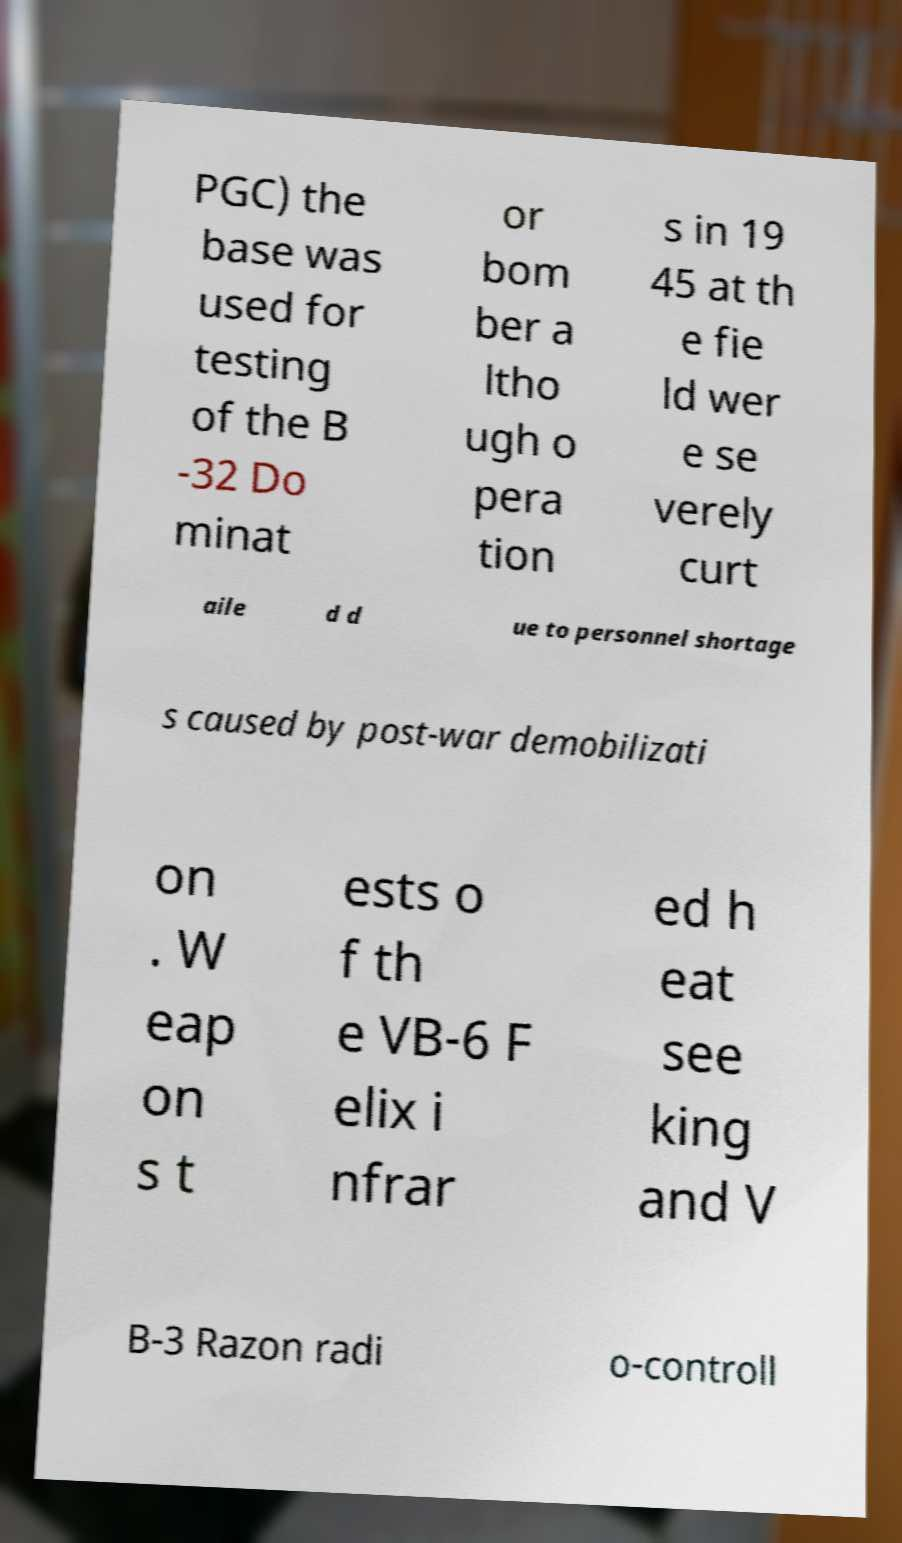Could you assist in decoding the text presented in this image and type it out clearly? PGC) the base was used for testing of the B -32 Do minat or bom ber a ltho ugh o pera tion s in 19 45 at th e fie ld wer e se verely curt aile d d ue to personnel shortage s caused by post-war demobilizati on . W eap on s t ests o f th e VB-6 F elix i nfrar ed h eat see king and V B-3 Razon radi o-controll 